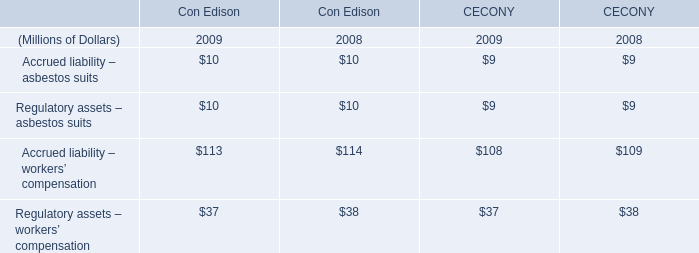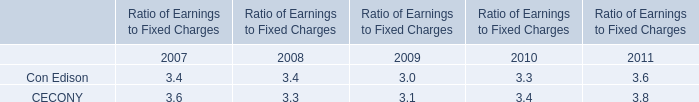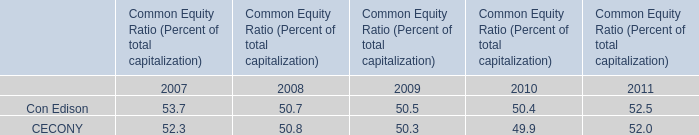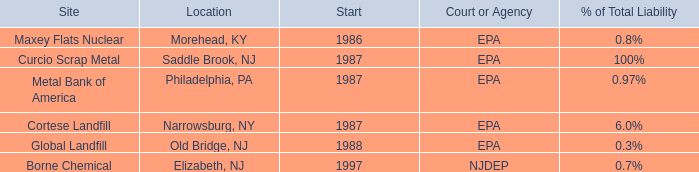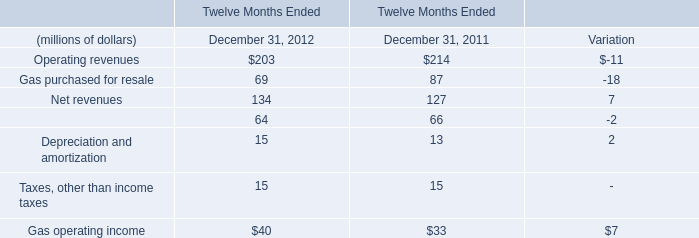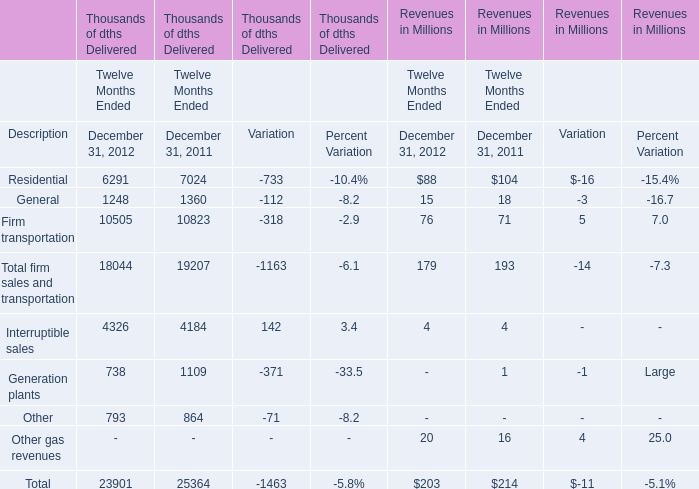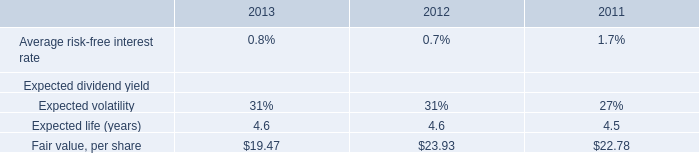what is the percentage change in the fair value per share between 2011 and 2012? 
Computations: ((23.93 - 22.78) / 22.78)
Answer: 0.05048. 